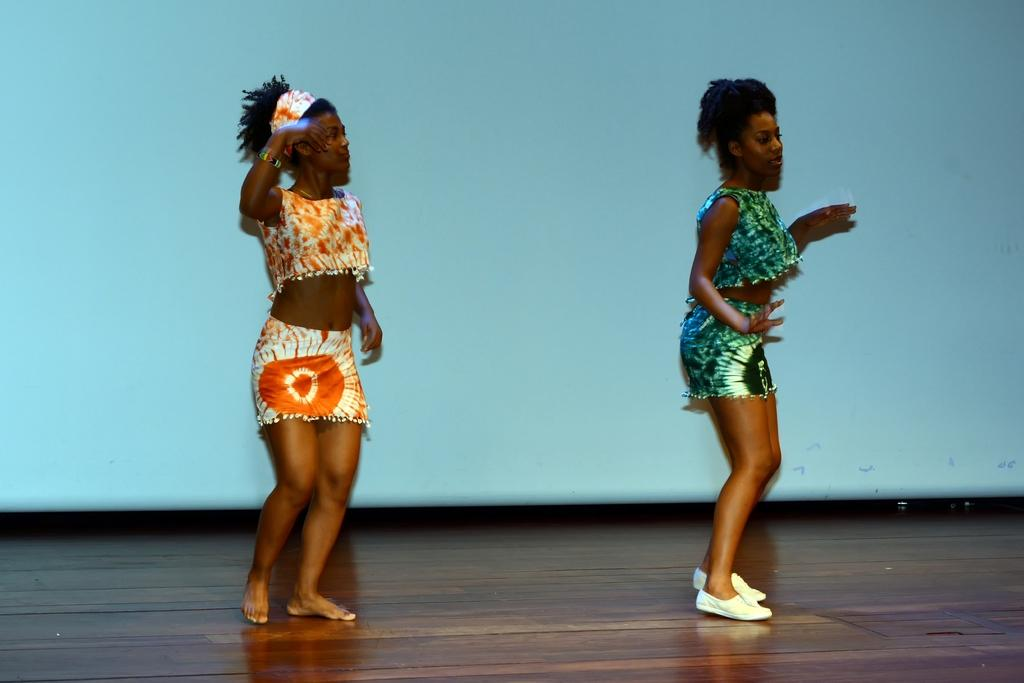How many people are present in the image? There are two women standing in the image. What is the women standing on in the image? There is a dais in the image. What color is the surface behind the women in the image? There is a blue surface in the backdrop of the image. Is there a bomb visible in the image? No, there is no bomb present in the image. How many people are shown caring for the women in the image? There is no indication of anyone caring for the women in the image. 